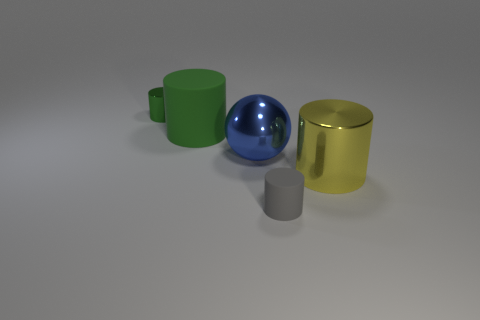How many yellow cylinders are the same size as the sphere?
Keep it short and to the point. 1. Is the size of the metallic cylinder to the left of the large metal sphere the same as the green cylinder in front of the tiny green shiny cylinder?
Make the answer very short. No. Is the number of shiny balls on the right side of the big blue object greater than the number of tiny green things behind the tiny green metal cylinder?
Keep it short and to the point. No. How many other tiny rubber objects have the same shape as the tiny gray thing?
Your answer should be very brief. 0. What material is the green cylinder that is the same size as the shiny sphere?
Offer a terse response. Rubber. Are there any small cylinders made of the same material as the sphere?
Offer a very short reply. Yes. Is the number of matte things that are behind the yellow shiny thing less than the number of large purple metal balls?
Provide a succinct answer. No. What material is the small cylinder behind the metallic cylinder in front of the tiny green cylinder?
Give a very brief answer. Metal. What is the shape of the thing that is both in front of the large blue metal object and behind the tiny gray matte cylinder?
Offer a terse response. Cylinder. What number of other objects are there of the same color as the small metallic thing?
Provide a short and direct response. 1. 